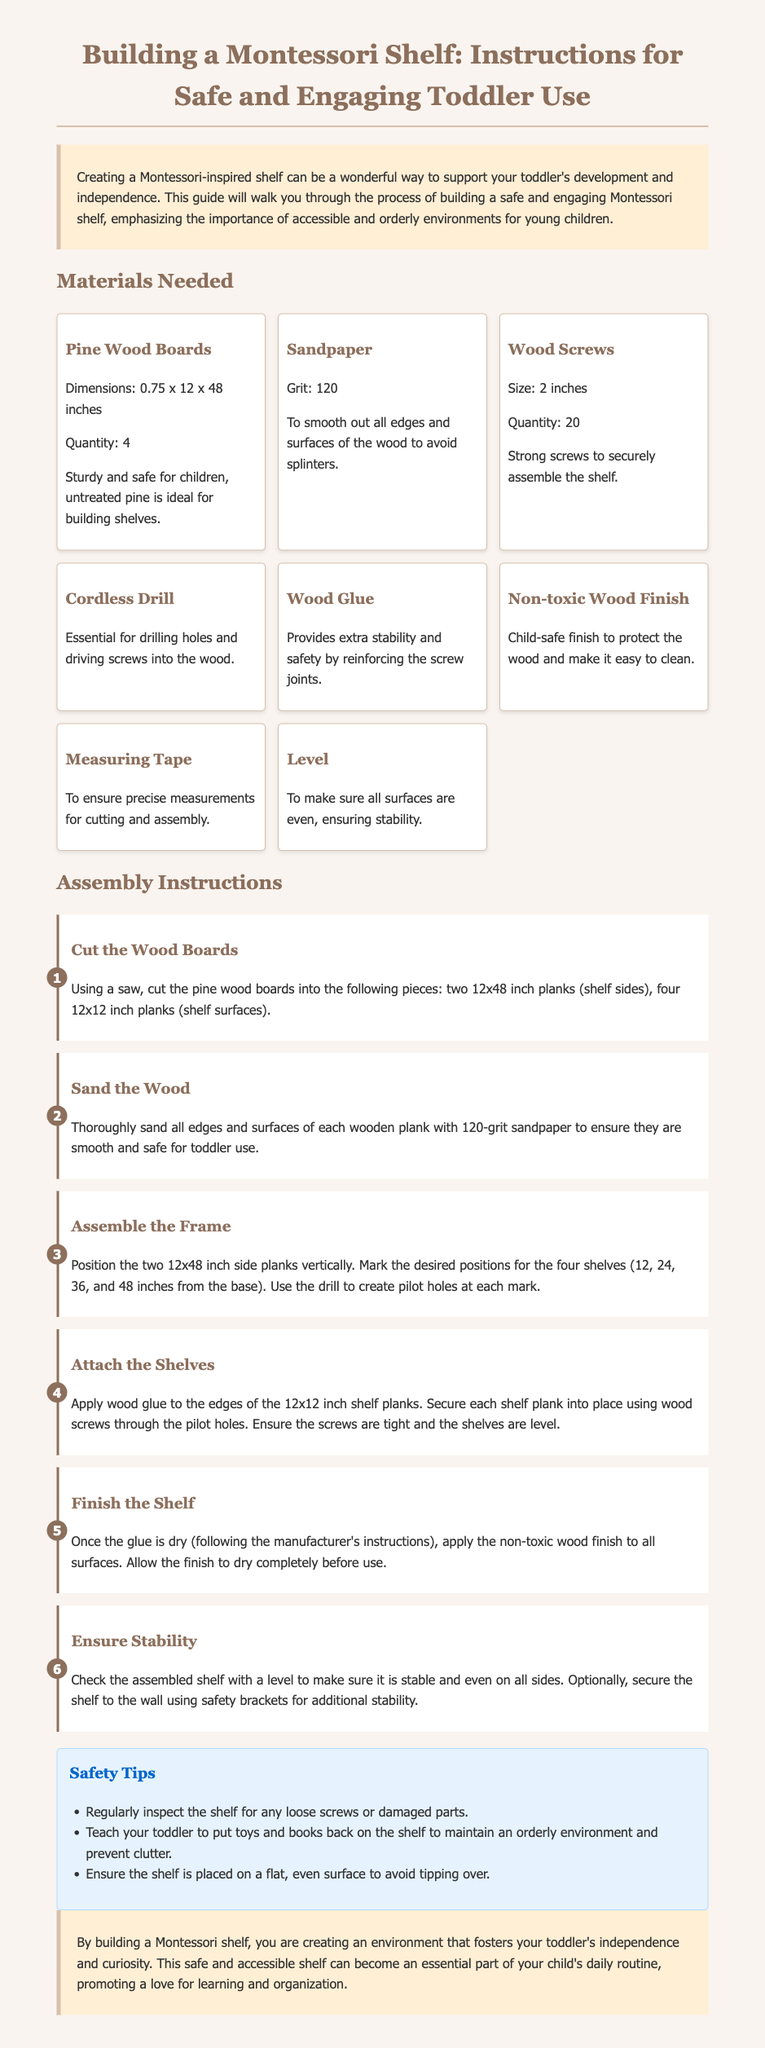what is the dimension of the pine wood boards? The dimensions of the pine wood boards are listed as 0.75 x 12 x 48 inches.
Answer: 0.75 x 12 x 48 inches how many wood screws are needed? The document specifies that a quantity of 20 wood screws is required for the assembly.
Answer: 20 what tool is essential for driving screws into the wood? The instructions mention a cordless drill as essential for drilling holes and driving screws.
Answer: Cordless Drill what grit of sandpaper is suggested? The document advises using 120 grit sandpaper for smoothing wood edges and surfaces.
Answer: 120 grit at what heights should the shelves be positioned? The instructions mention marking the shelves at heights of 12, 24, 36, and 48 inches from the base.
Answer: 12, 24, 36, and 48 inches what should be done to ensure the shelf is stable? The assembly instructions recommend checking the shelf with a level to make sure it is stable and even.
Answer: Check with a level what is the purpose of wood glue in the assembly? The document indicates that wood glue provides extra stability and safety by reinforcing the screw joints.
Answer: Extra stability how often should the shelf be inspected for safety? The safety tips recommend regularly inspecting the shelf for any loose screws or damaged parts.
Answer: Regularly what is the final step in finishing the shelf? The last step mentioned involves applying the non-toxic wood finish to all surfaces and allowing it to dry completely.
Answer: Allow to dry completely 